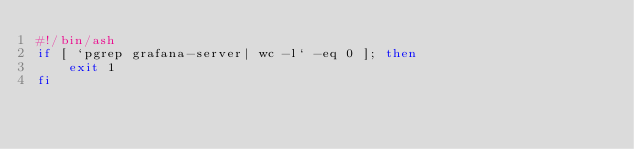Convert code to text. <code><loc_0><loc_0><loc_500><loc_500><_Bash_>#!/bin/ash
if [ `pgrep grafana-server| wc -l` -eq 0 ]; then
    exit 1
fi</code> 